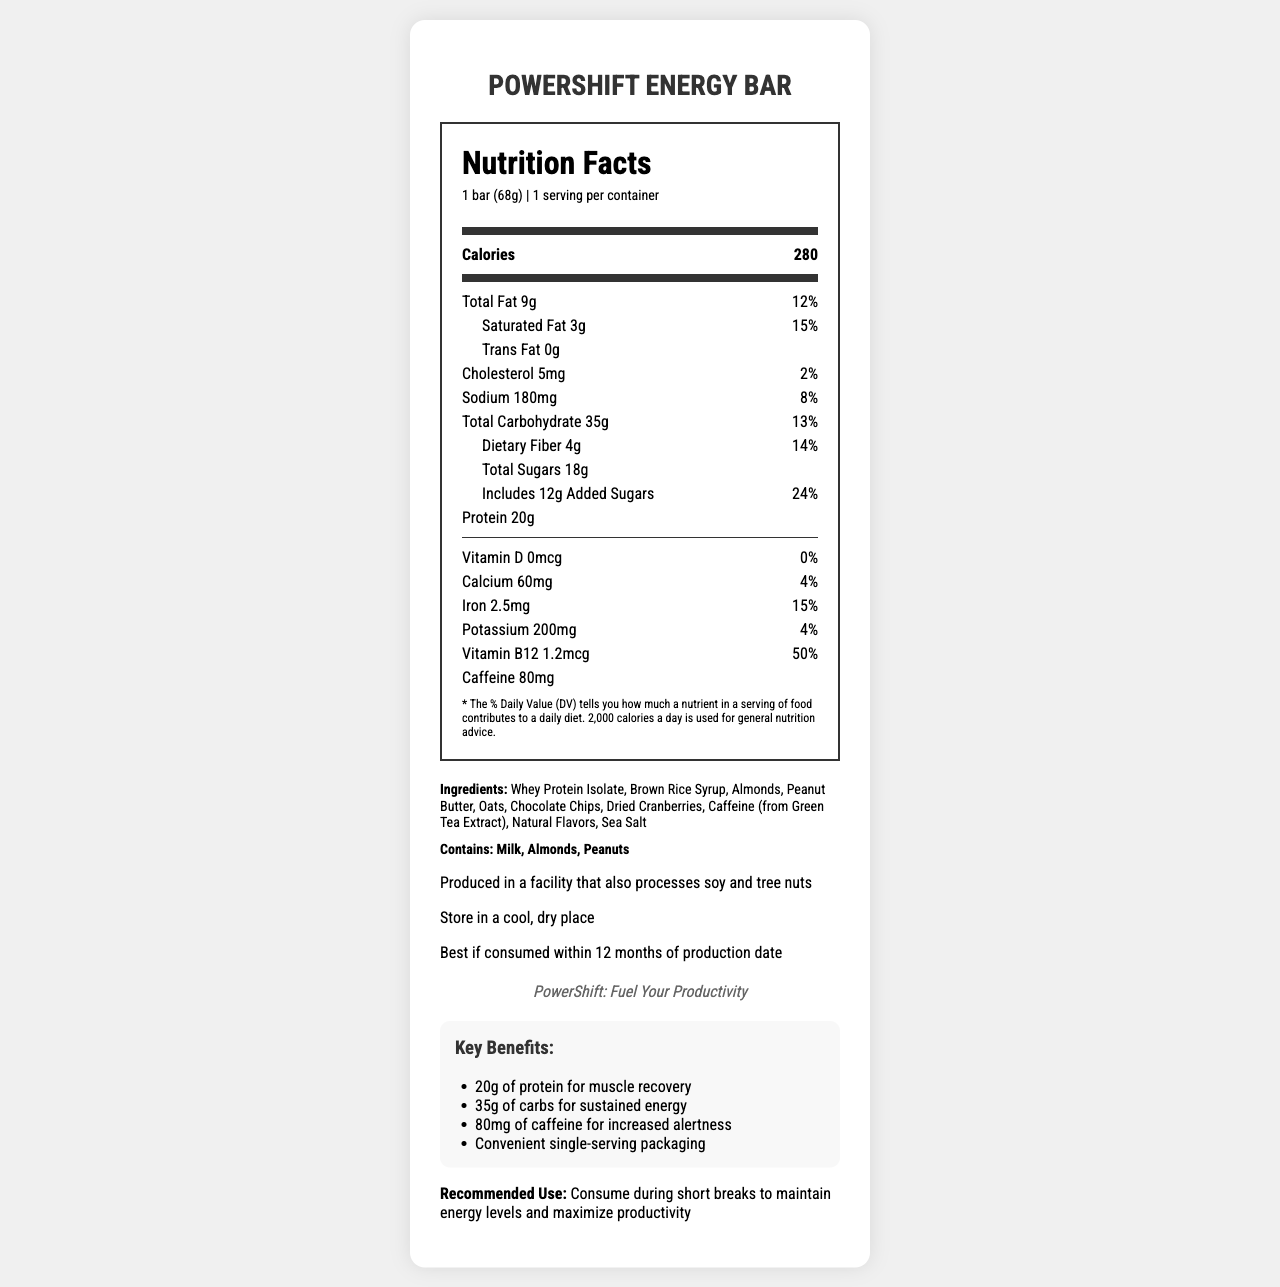What is the serving size of the PowerShift Energy Bar? The serving size is explicitly mentioned as "1 bar (68g)" in the document.
Answer: 1 bar (68g) How many calories are present in one serving of the PowerShift Energy Bar? The document states that there are 280 calories per serving.
Answer: 280 What is the amount of protein in this energy bar? The amount of protein is listed as "20g" in the nutrition facts.
Answer: 20g Which ingredients in the PowerShift Energy Bar may cause allergies? The allergen information clearly states that the bar contains Milk, Almonds, and Peanuts.
Answer: Milk, Almonds, Peanuts What is the daily value percentage of added sugars in this bar? The daily value percentage for added sugars is explicitly mentioned as "24%".
Answer: 24% What is the source of caffeine in the PowerShift Energy Bar? A. Caffeine Anhydrous B. Green Tea Extract C. Coffee Beans D. Guarana Extract The document lists "Caffeine (from Green Tea Extract)" in the ingredients list.
Answer: B. Green Tea Extract What is the highest daily value percentage nutrient in the PowerShift Energy Bar?  A. Vitamin D B. Calcium  C. Iron  D. Vitamin B12 Vitamin B12 has the highest daily value percentage at 50%.
Answer: D. Vitamin B12 Does the PowerShift Energy Bar contain any trans fats? The document lists "Trans Fat 0g", indicating that it does not contain any trans fats.
Answer: No Summarize the key benefits of the PowerShift Energy Bar as stated in the document. These benefits are highlighted under the "Key Benefits" section in the document.
Answer: The key benefits are: 20g of protein for muscle recovery, 35g of carbs for sustained energy, 80mg of caffeine for increased alertness, and convenient single-serving packaging. Does the PowerShift Energy Bar provide any vitamin D? The nutrition facts state "Vitamin D 0mcg" with a daily value of 0%, indicating that it does not provide any vitamin D.
Answer: No What is the intended use for the PowerShift Energy Bar according to the document? The document recommends this bar for consumption during short breaks to help maintain energy levels and maximize productivity.
Answer: Consume during short breaks to maintain energy levels and maximize productivity Who is the target audience for the PowerShift Energy Bar? The document specifies that the target audience is production workers seeking quick, high-energy snacks.
Answer: Production workers seeking quick, high-energy snacks Can the average daily calorie intake be determined from the document? While the document provides detailed nutritional information about the bar, it does not give enough information to determine an average daily calorie intake.
Answer: No, cannot be determined 